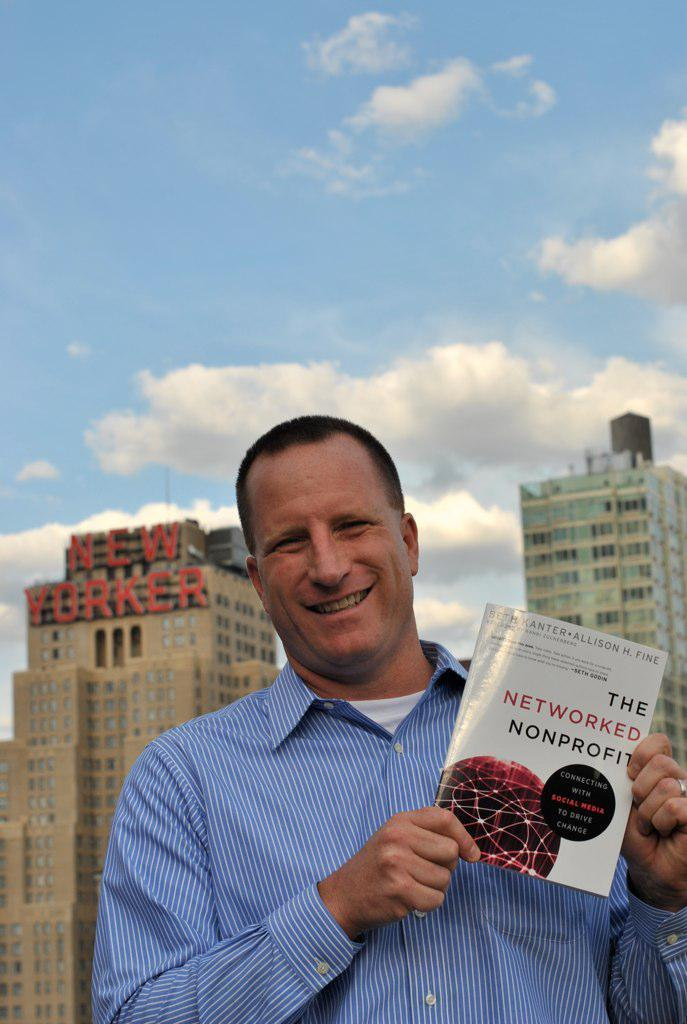<image>
Offer a succinct explanation of the picture presented. The Networked Nonprofit book by Seth Kanter and Allison H. Fine. 